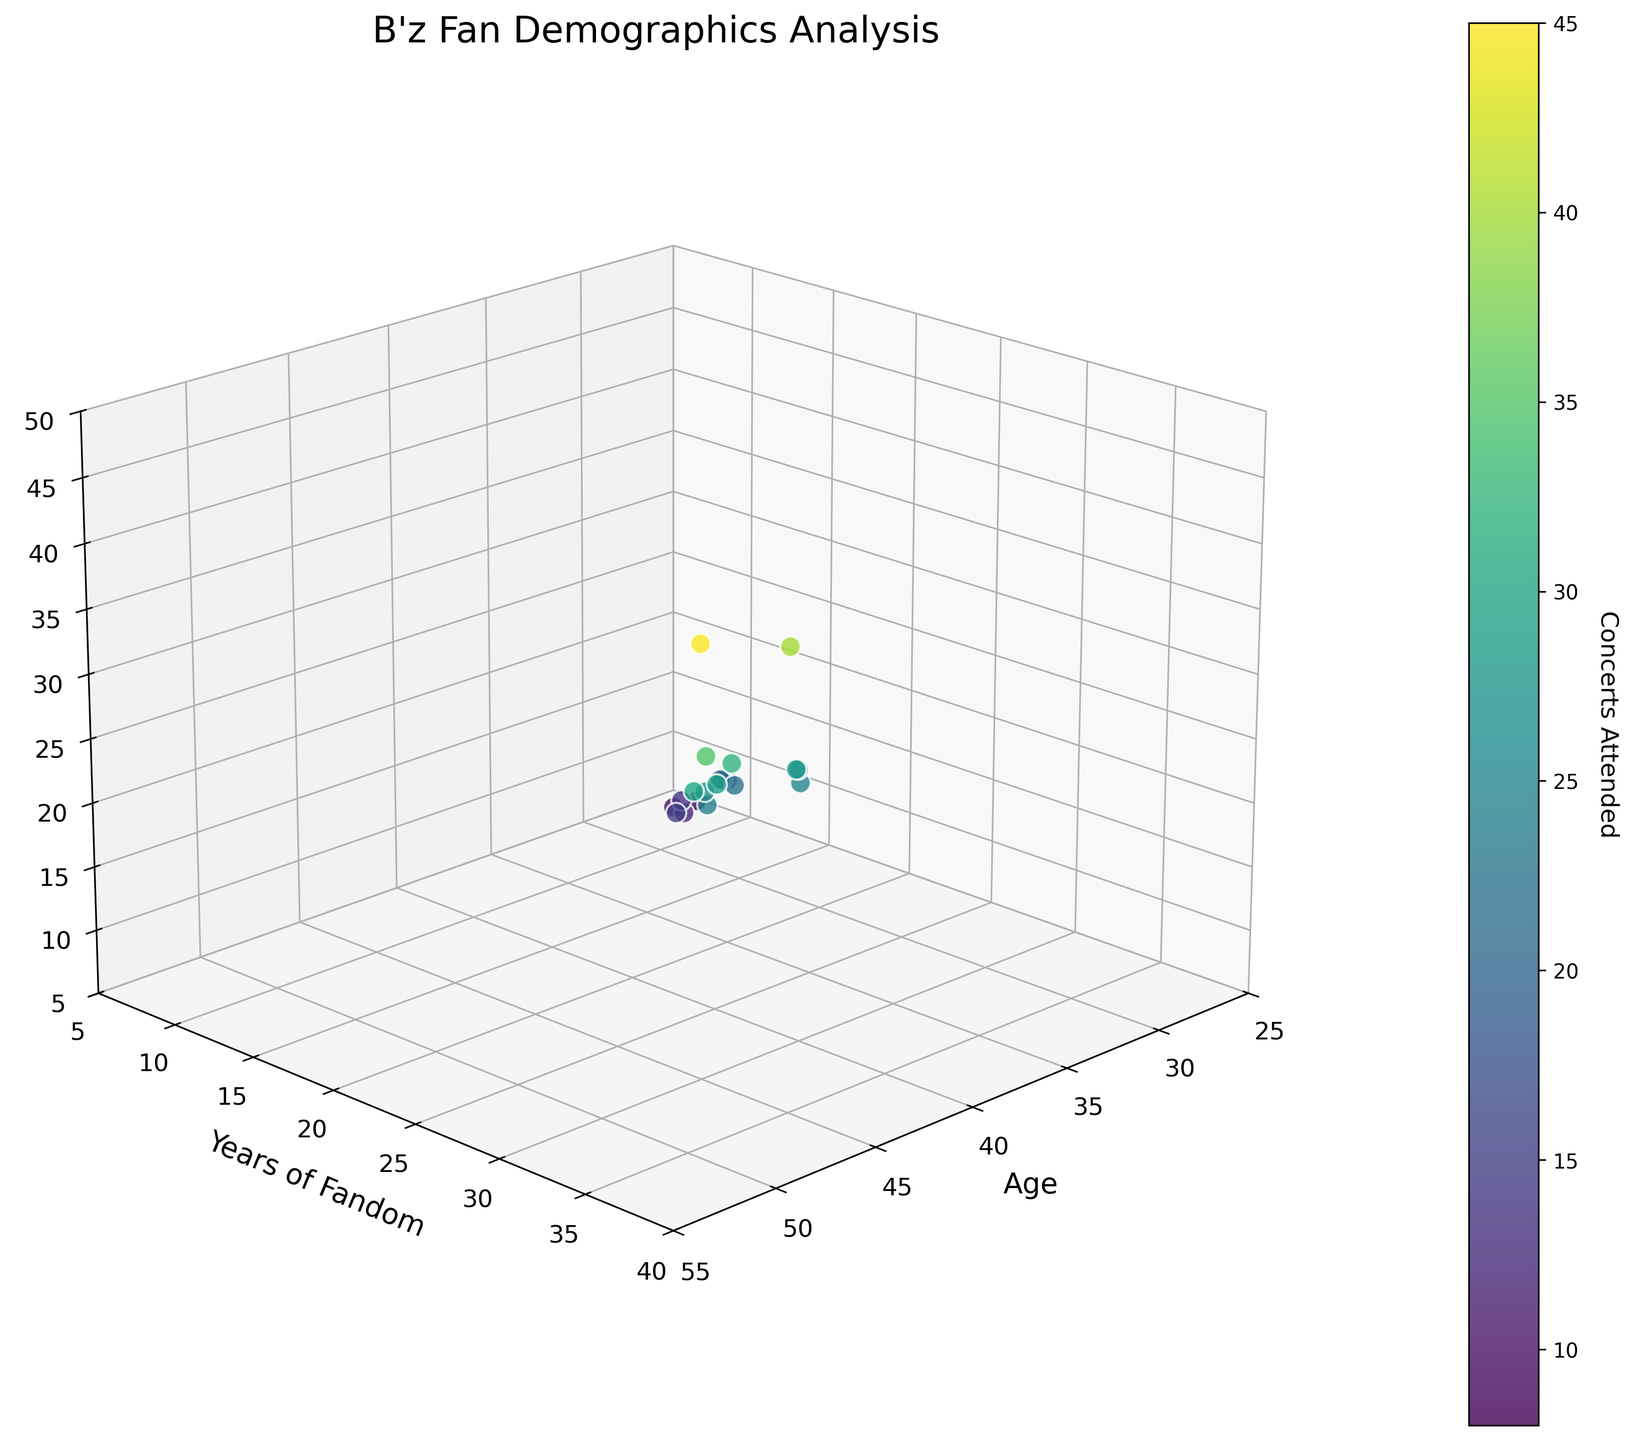How many data points are represented in the plot? By counting the number of dots on the 3D scatter plot, we can determine the number of data points. Each dot represents one fan demographic
Answer: 20 What are the axis labels of the plot? The axis labels are shown near each axis. The x-axis is labeled 'Age', the y-axis is labeled 'Years of Fandom', and the z-axis is labeled 'Concerts Attended'
Answer: 'Age', 'Years of Fandom', 'Concerts Attended' What's the age range represented in the plot? Look at the range of values on the x-axis, which represents 'Age'. The minimum age is 28, and the maximum age is 52
Answer: 28 to 52 What's the overall trend between years of fandom and concerts attended? Observing the plot, you can see that as the 'Years of Fandom' increases along the y-axis, the number of 'Concerts Attended' also increases along the z-axis, indicating a positive correlation
Answer: Positive correlation Which age group has attended the most concerts? Identify the point with the highest value on the z-axis ('Concerts Attended') and check the corresponding x-axis ('Age') value. The highest number of concerts attended is 45, and the age corresponding to this point is 52
Answer: 52 What's the average number of concerts attended by fans who are 40 years old? Locate the data points where 'Age' is 40. Then, find the average of the corresponding 'Concerts Attended' values. Here, it is only one data point (25)
Answer: 25 Is there a fan with fewer than 10 concerts attended? If so, what's their age? Look for points on the z-axis with values less than 10 and then check their corresponding x-axis positions for their ages. The ages are 28 and 31
Answer: 28 and 31 Which age group has the highest number of years of fandom? Identify the point with the highest y-axis value ('Years of Fandom') and check its corresponding x-axis value ('Age'). The highest 'Years of Fandom' is 38, corresponding to age 52
Answer: 52 How many fans have attended more than 30 concerts? Count the number of points where the z-axis ('Concerts Attended') values are greater than 30. These points are at ages 45, 48, 50, and 52
Answer: 4 What's the relationship between age and years of fandom for fans who attended 20 or more concerts? Identify data points on the z-axis with values of 20 or more concerts and observe the corresponding x-axis (age) and y-axis (years of fandom) values. The relationship shows that typically, older fans have more years of fandom
Answer: Older fans generally have more years of fandom 